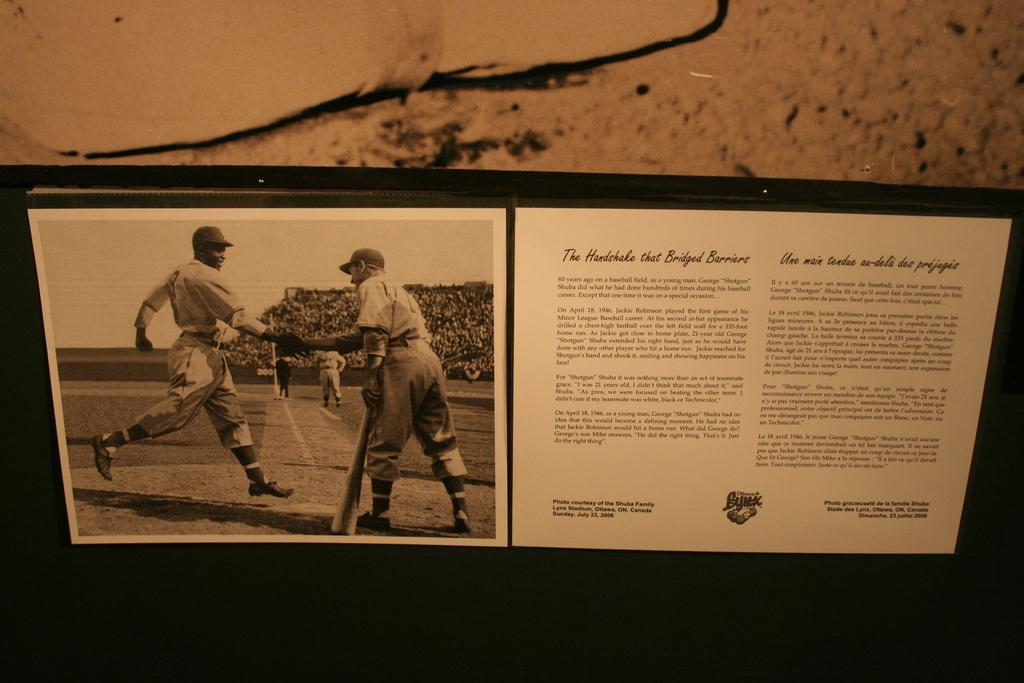What is the main object in the image? There is a poster in the image. What can be found on the poster? The poster contains images and text. What can be seen behind the poster? The background is visible in the image. What type of brake is depicted on the poster? There is no brake depicted on the poster; it contains images and text related to a different subject. 